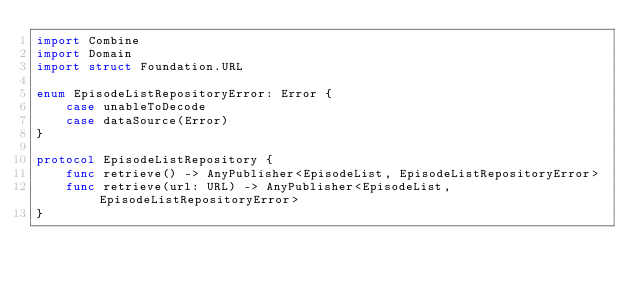<code> <loc_0><loc_0><loc_500><loc_500><_Swift_>import Combine
import Domain
import struct Foundation.URL

enum EpisodeListRepositoryError: Error {
    case unableToDecode
    case dataSource(Error)
}

protocol EpisodeListRepository {
    func retrieve() -> AnyPublisher<EpisodeList, EpisodeListRepositoryError>
    func retrieve(url: URL) -> AnyPublisher<EpisodeList, EpisodeListRepositoryError>
}
</code> 